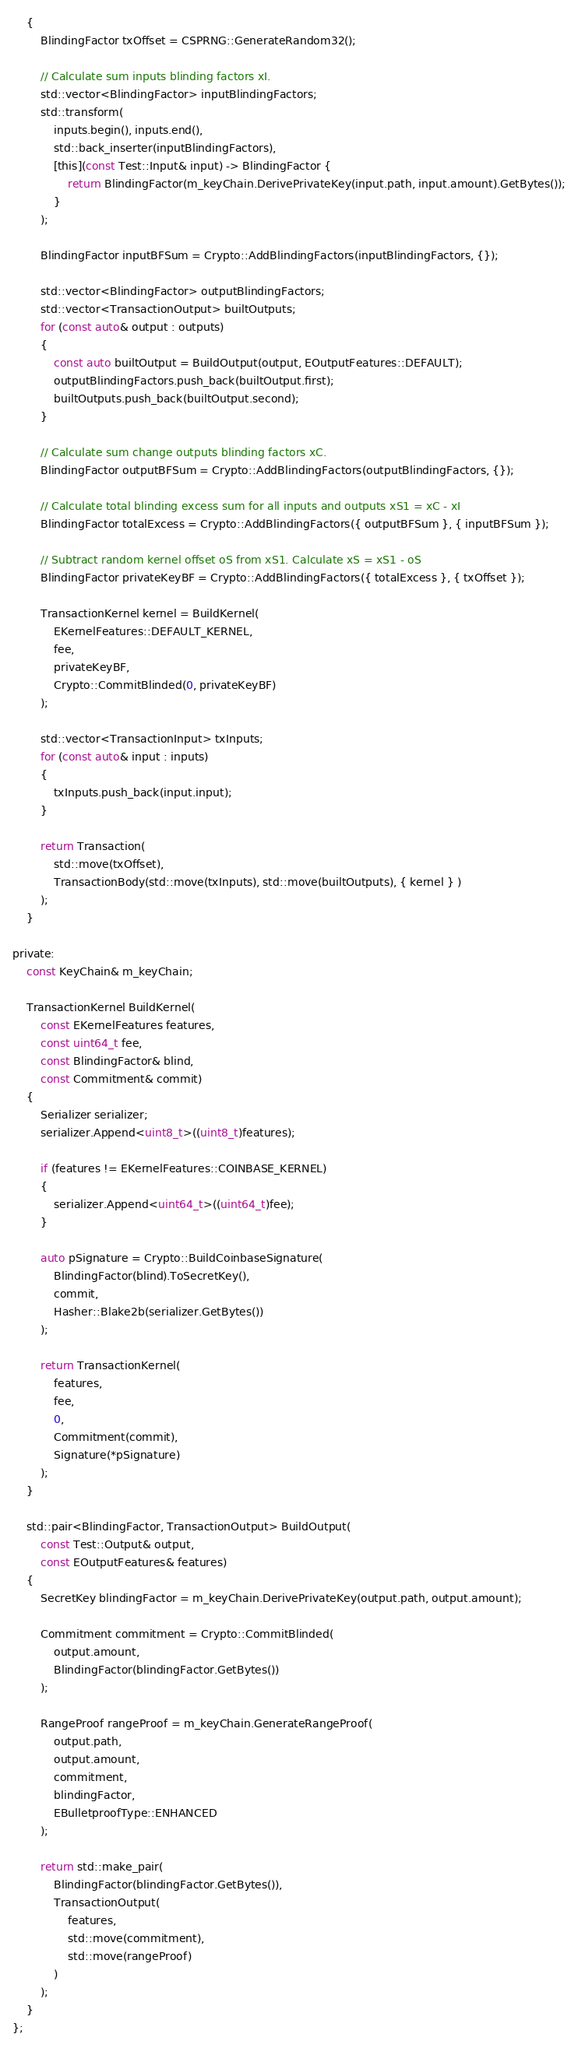Convert code to text. <code><loc_0><loc_0><loc_500><loc_500><_C_>    {
        BlindingFactor txOffset = CSPRNG::GenerateRandom32();

        // Calculate sum inputs blinding factors xI.
        std::vector<BlindingFactor> inputBlindingFactors;
        std::transform(
            inputs.begin(), inputs.end(),
            std::back_inserter(inputBlindingFactors),
            [this](const Test::Input& input) -> BlindingFactor {
                return BlindingFactor(m_keyChain.DerivePrivateKey(input.path, input.amount).GetBytes());
            }
        );

        BlindingFactor inputBFSum = Crypto::AddBlindingFactors(inputBlindingFactors, {});

        std::vector<BlindingFactor> outputBlindingFactors;
        std::vector<TransactionOutput> builtOutputs;
        for (const auto& output : outputs)
        {
            const auto builtOutput = BuildOutput(output, EOutputFeatures::DEFAULT);
            outputBlindingFactors.push_back(builtOutput.first);
            builtOutputs.push_back(builtOutput.second);
        }

        // Calculate sum change outputs blinding factors xC.
        BlindingFactor outputBFSum = Crypto::AddBlindingFactors(outputBlindingFactors, {});

        // Calculate total blinding excess sum for all inputs and outputs xS1 = xC - xI
        BlindingFactor totalExcess = Crypto::AddBlindingFactors({ outputBFSum }, { inputBFSum });

        // Subtract random kernel offset oS from xS1. Calculate xS = xS1 - oS
        BlindingFactor privateKeyBF = Crypto::AddBlindingFactors({ totalExcess }, { txOffset });

        TransactionKernel kernel = BuildKernel(
            EKernelFeatures::DEFAULT_KERNEL,
            fee,
            privateKeyBF,
            Crypto::CommitBlinded(0, privateKeyBF)
        );

        std::vector<TransactionInput> txInputs;
        for (const auto& input : inputs)
        {
            txInputs.push_back(input.input);
        }

        return Transaction(
            std::move(txOffset),
            TransactionBody(std::move(txInputs), std::move(builtOutputs), { kernel } )
        );
    }

private:
    const KeyChain& m_keyChain;

    TransactionKernel BuildKernel(
        const EKernelFeatures features,
        const uint64_t fee,
        const BlindingFactor& blind,
        const Commitment& commit)
    {
        Serializer serializer;
        serializer.Append<uint8_t>((uint8_t)features);

        if (features != EKernelFeatures::COINBASE_KERNEL)
        {
            serializer.Append<uint64_t>((uint64_t)fee);
        }

        auto pSignature = Crypto::BuildCoinbaseSignature(
            BlindingFactor(blind).ToSecretKey(),
            commit,
            Hasher::Blake2b(serializer.GetBytes())
        );

        return TransactionKernel(
            features,
            fee,
            0,
            Commitment(commit),
            Signature(*pSignature)
        );
    }

    std::pair<BlindingFactor, TransactionOutput> BuildOutput(
        const Test::Output& output,
        const EOutputFeatures& features)
    {
        SecretKey blindingFactor = m_keyChain.DerivePrivateKey(output.path, output.amount);

        Commitment commitment = Crypto::CommitBlinded(
            output.amount,
            BlindingFactor(blindingFactor.GetBytes())
        );

        RangeProof rangeProof = m_keyChain.GenerateRangeProof(
            output.path,
            output.amount,
            commitment,
            blindingFactor,
            EBulletproofType::ENHANCED
        );

        return std::make_pair(
            BlindingFactor(blindingFactor.GetBytes()),
            TransactionOutput(
                features,
                std::move(commitment),
                std::move(rangeProof)
            )
        );
    }
};</code> 